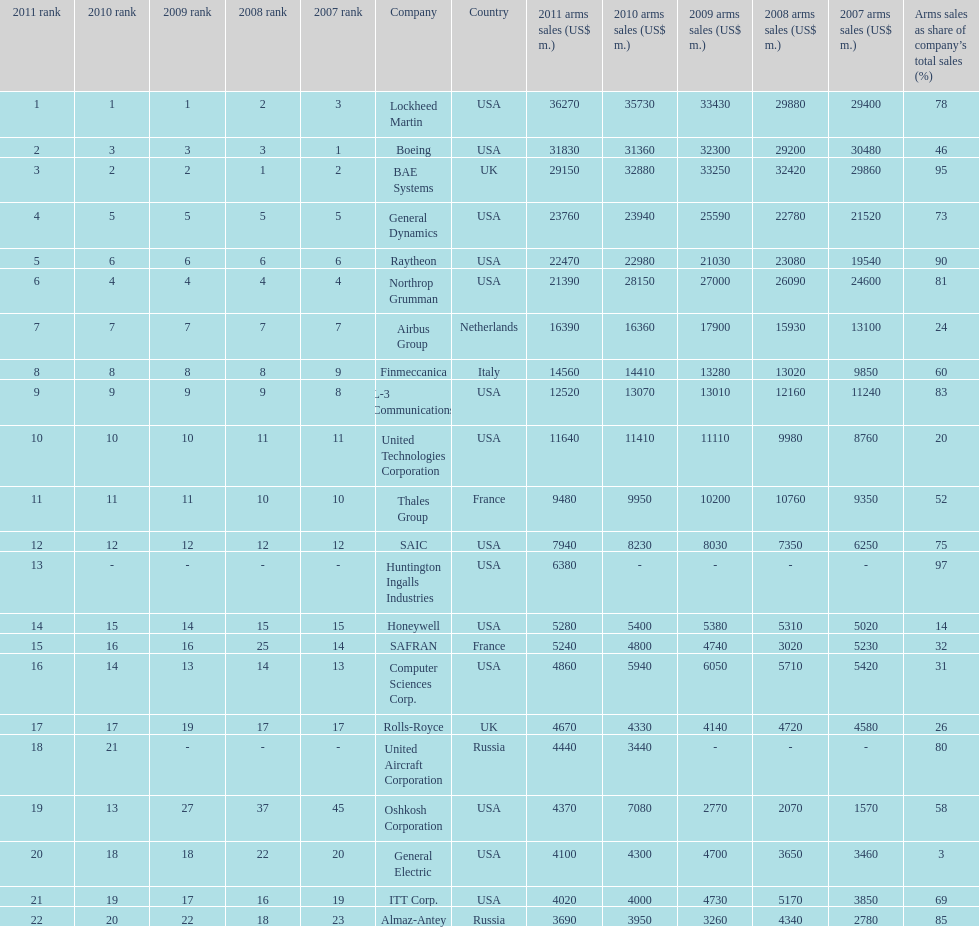How many different countries are listed? 6. 